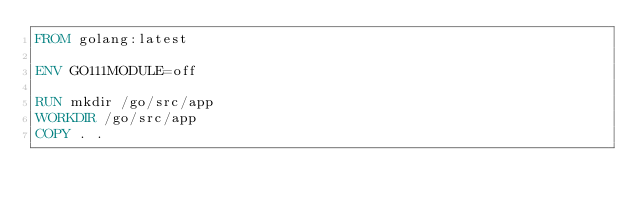Convert code to text. <code><loc_0><loc_0><loc_500><loc_500><_Dockerfile_>FROM golang:latest

ENV GO111MODULE=off

RUN mkdir /go/src/app
WORKDIR /go/src/app
COPY . .
</code> 